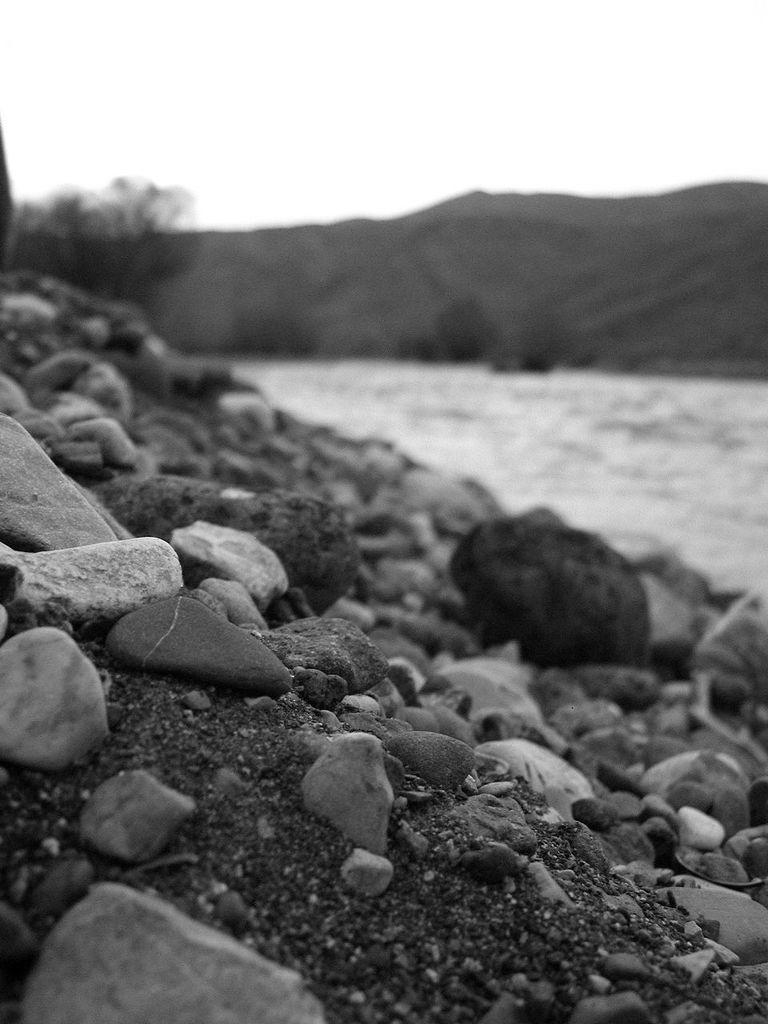What is the color scheme of the image? The image is black and white. What type of natural features can be seen in the image? There are rocks, a hill, and a tree in the image. Can you see an owl perched on the tree in the image? There is no owl present in the image; it only features rocks, a hill, and a tree. 